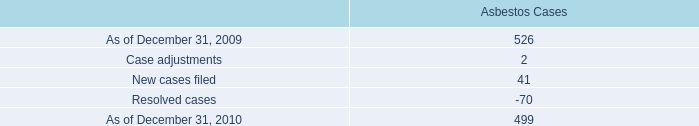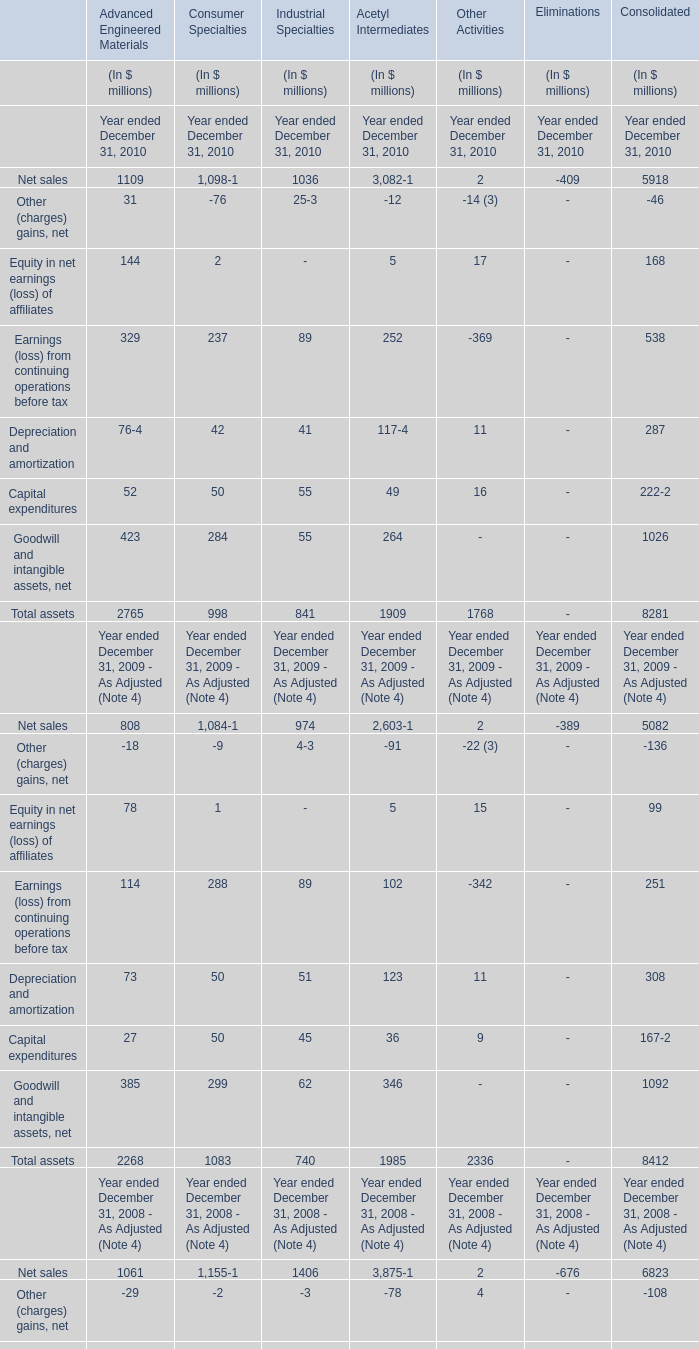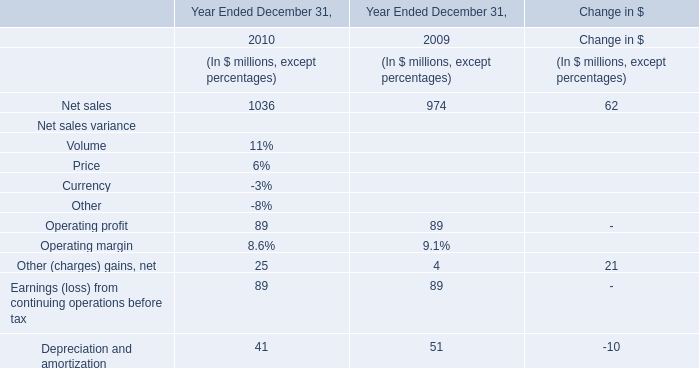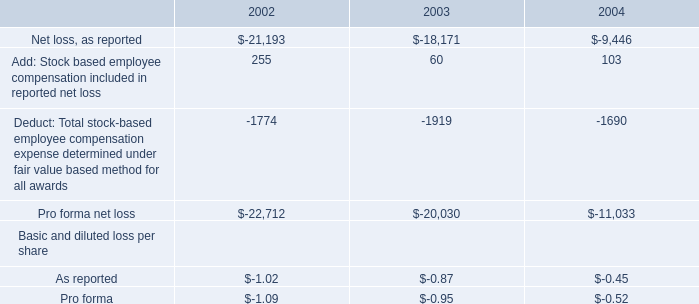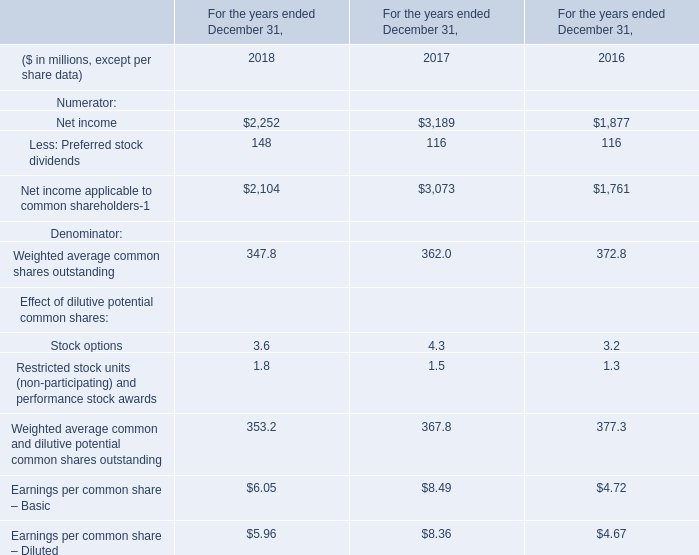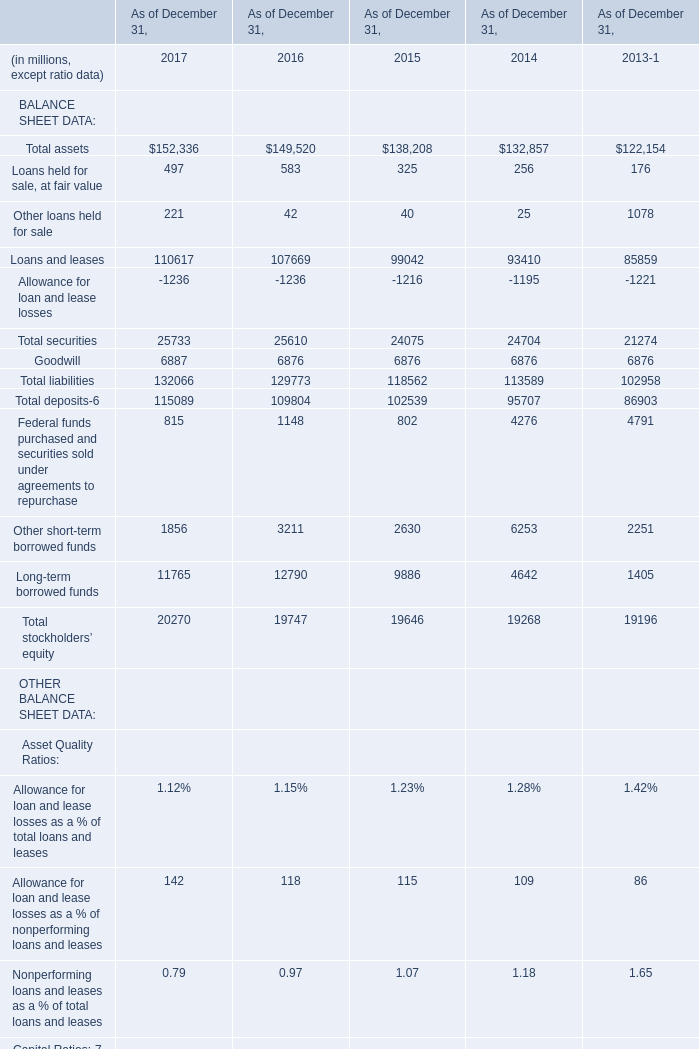What is the growing rate of Total liabilities in the year with the most Loans and leases? 
Computations: ((132066 - 129773) / 129773)
Answer: 0.01767. 